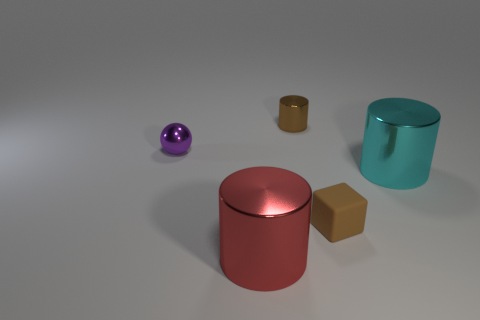What number of other things are the same color as the rubber object?
Make the answer very short. 1. Are there fewer rubber cubes than big yellow cylinders?
Ensure brevity in your answer.  No. The shiny thing that is left of the large metallic object that is on the left side of the tiny brown cylinder is what shape?
Make the answer very short. Sphere. There is a small brown matte cube; are there any small purple balls in front of it?
Your answer should be very brief. No. What is the color of the cylinder that is the same size as the matte thing?
Your answer should be very brief. Brown. How many large cyan cylinders have the same material as the small purple thing?
Your answer should be very brief. 1. How many other objects are there of the same size as the red thing?
Ensure brevity in your answer.  1. Are there any objects that have the same size as the cyan cylinder?
Provide a succinct answer. Yes. There is a big cylinder in front of the small block; is its color the same as the matte cube?
Make the answer very short. No. How many things are either small red metallic balls or small brown matte objects?
Offer a terse response. 1. 